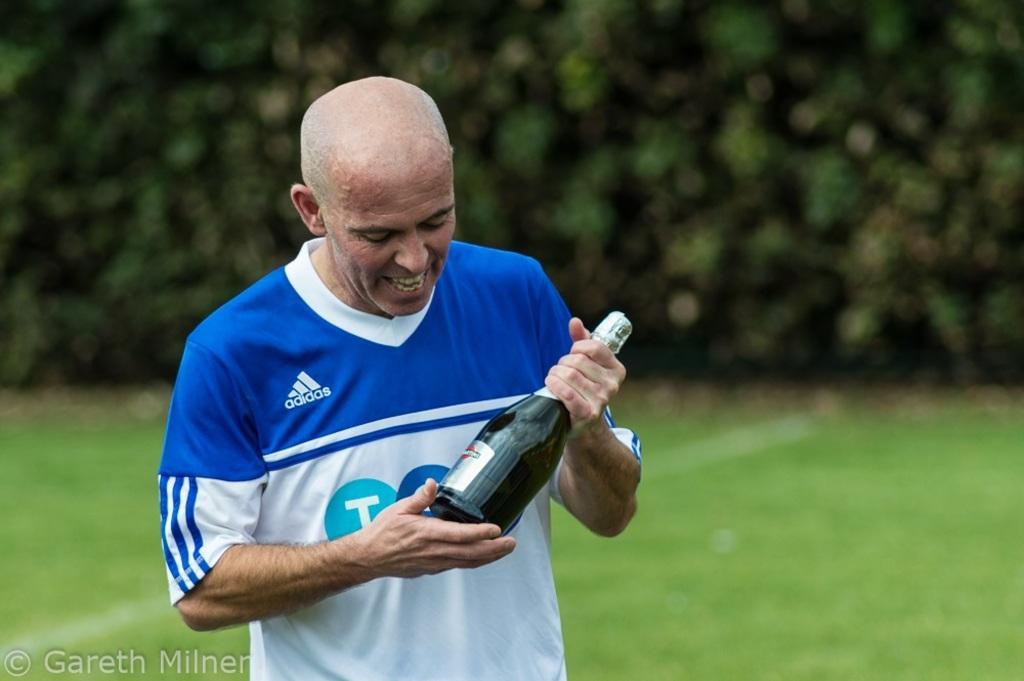Who is present in the image? There is a man in the image. What is the man wearing? The man is wearing a blue t-shirt. What is the man holding in the image? The man is holding a bottle. What can be seen in the background of the image? There are trees and grass visible in the background of the image. How does the man push the dirt away in the image? There is no dirt present in the image, and the man is not shown pushing anything away. 